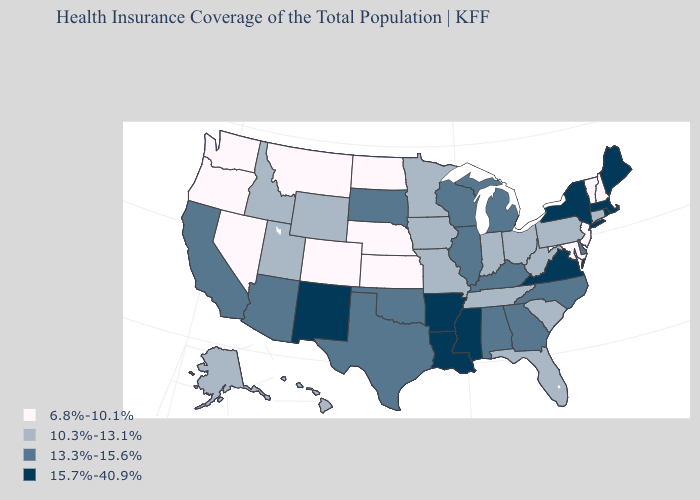What is the lowest value in the South?
Answer briefly. 6.8%-10.1%. What is the lowest value in the West?
Concise answer only. 6.8%-10.1%. What is the value of Minnesota?
Concise answer only. 10.3%-13.1%. Does the first symbol in the legend represent the smallest category?
Quick response, please. Yes. What is the value of Iowa?
Short answer required. 10.3%-13.1%. Name the states that have a value in the range 6.8%-10.1%?
Write a very short answer. Colorado, Kansas, Maryland, Montana, Nebraska, Nevada, New Hampshire, New Jersey, North Dakota, Oregon, Vermont, Washington. Is the legend a continuous bar?
Short answer required. No. Among the states that border Texas , which have the lowest value?
Be succinct. Oklahoma. Name the states that have a value in the range 6.8%-10.1%?
Answer briefly. Colorado, Kansas, Maryland, Montana, Nebraska, Nevada, New Hampshire, New Jersey, North Dakota, Oregon, Vermont, Washington. Name the states that have a value in the range 13.3%-15.6%?
Short answer required. Alabama, Arizona, California, Delaware, Georgia, Illinois, Kentucky, Michigan, North Carolina, Oklahoma, South Dakota, Texas, Wisconsin. Which states hav the highest value in the West?
Write a very short answer. New Mexico. Name the states that have a value in the range 6.8%-10.1%?
Write a very short answer. Colorado, Kansas, Maryland, Montana, Nebraska, Nevada, New Hampshire, New Jersey, North Dakota, Oregon, Vermont, Washington. Name the states that have a value in the range 15.7%-40.9%?
Give a very brief answer. Arkansas, Louisiana, Maine, Massachusetts, Mississippi, New Mexico, New York, Rhode Island, Virginia. Does Indiana have the lowest value in the MidWest?
Keep it brief. No. 